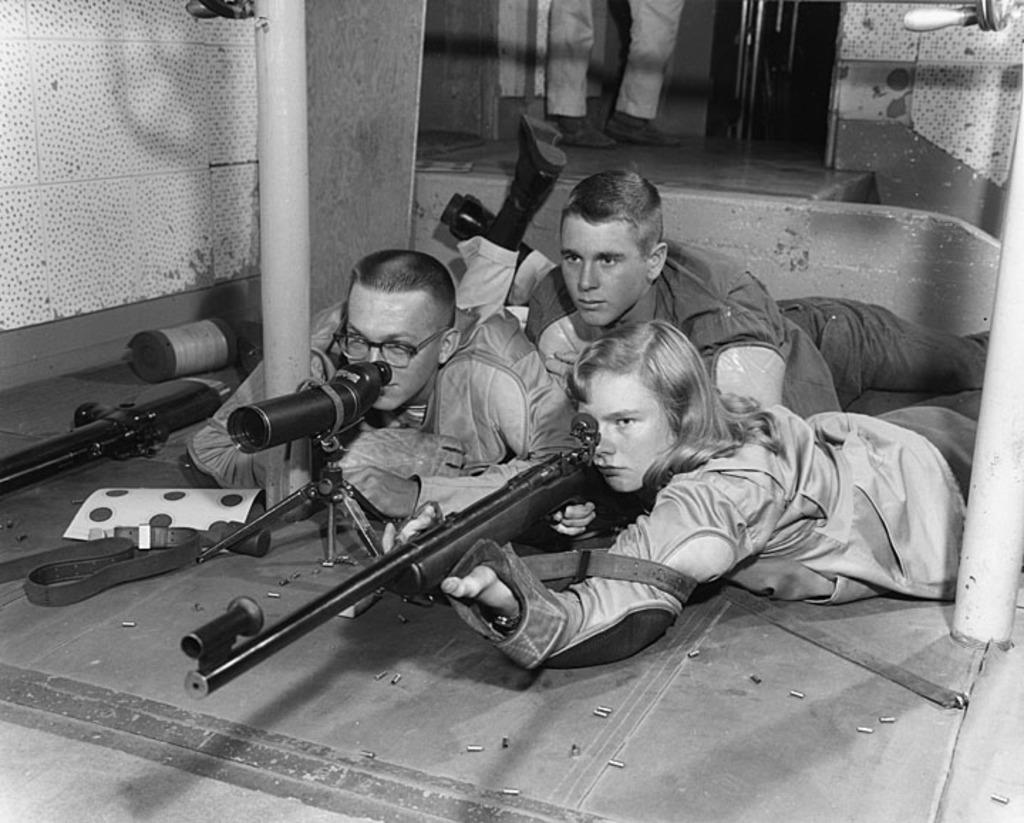How would you summarize this image in a sentence or two? This is a black and white picture. I can see three persons lying, there is a person holding a rifle, there is a telescope with a stand, there are some objects, and in the background there are legs of a person. 